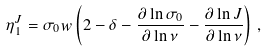Convert formula to latex. <formula><loc_0><loc_0><loc_500><loc_500>\eta _ { 1 } ^ { J } = \sigma _ { 0 } w \left ( 2 - \delta - \frac { \partial \ln \sigma _ { 0 } } { \partial \ln \nu } - \frac { \partial \ln J } { \partial \ln \nu } \right ) \, ,</formula> 